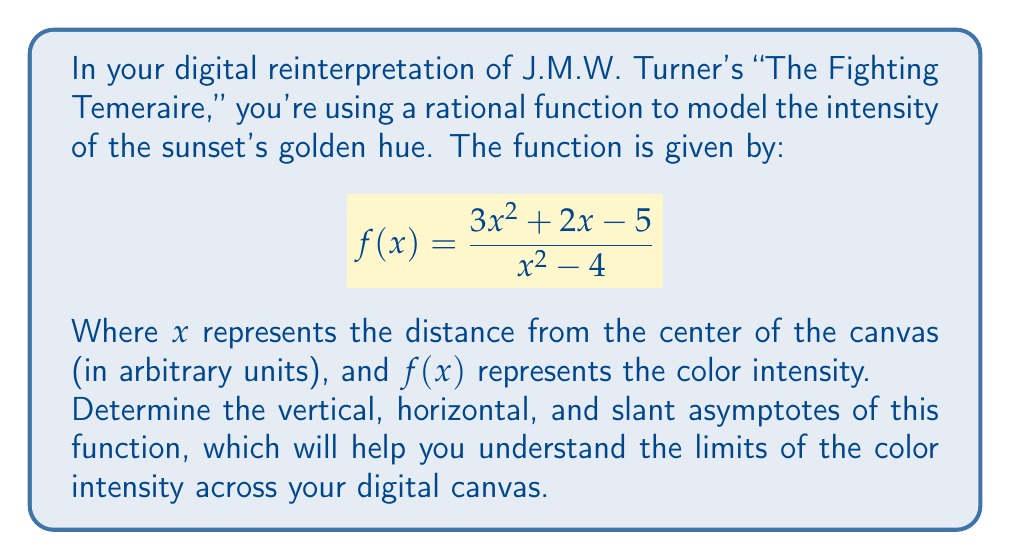Can you answer this question? Let's approach this step-by-step:

1) Vertical Asymptotes:
   Vertical asymptotes occur where the denominator equals zero.
   $x^2 - 4 = 0$
   $(x+2)(x-2) = 0$
   $x = 2$ or $x = -2$

2) Horizontal Asymptote:
   To find the horizontal asymptote, we compare the degrees of the numerator and denominator.
   Both have degree 2, so we divide the leading coefficients:
   $\lim_{x \to \infty} \frac{3x^2}{x^2} = 3$

3) Slant Asymptote:
   Since the degree of the numerator equals the degree of the denominator, there is no slant asymptote.

4) To verify the horizontal asymptote, we can use polynomial long division:

   $$\frac{3x^2 + 2x - 5}{x^2 - 4} = 3 + \frac{2x + 7}{x^2 - 4}$$

   As $x$ approaches infinity, $\frac{2x + 7}{x^2 - 4}$ approaches 0, confirming the horizontal asymptote of $y = 3$.

This analysis shows that the color intensity approaches 3 as we move far from the center, and there are two vertical lines (at $x = 2$ and $x = -2$) where the function is undefined, potentially creating sharp contrasts in your digital artwork.
Answer: Vertical asymptotes: $x = 2$, $x = -2$; Horizontal asymptote: $y = 3$; No slant asymptote. 